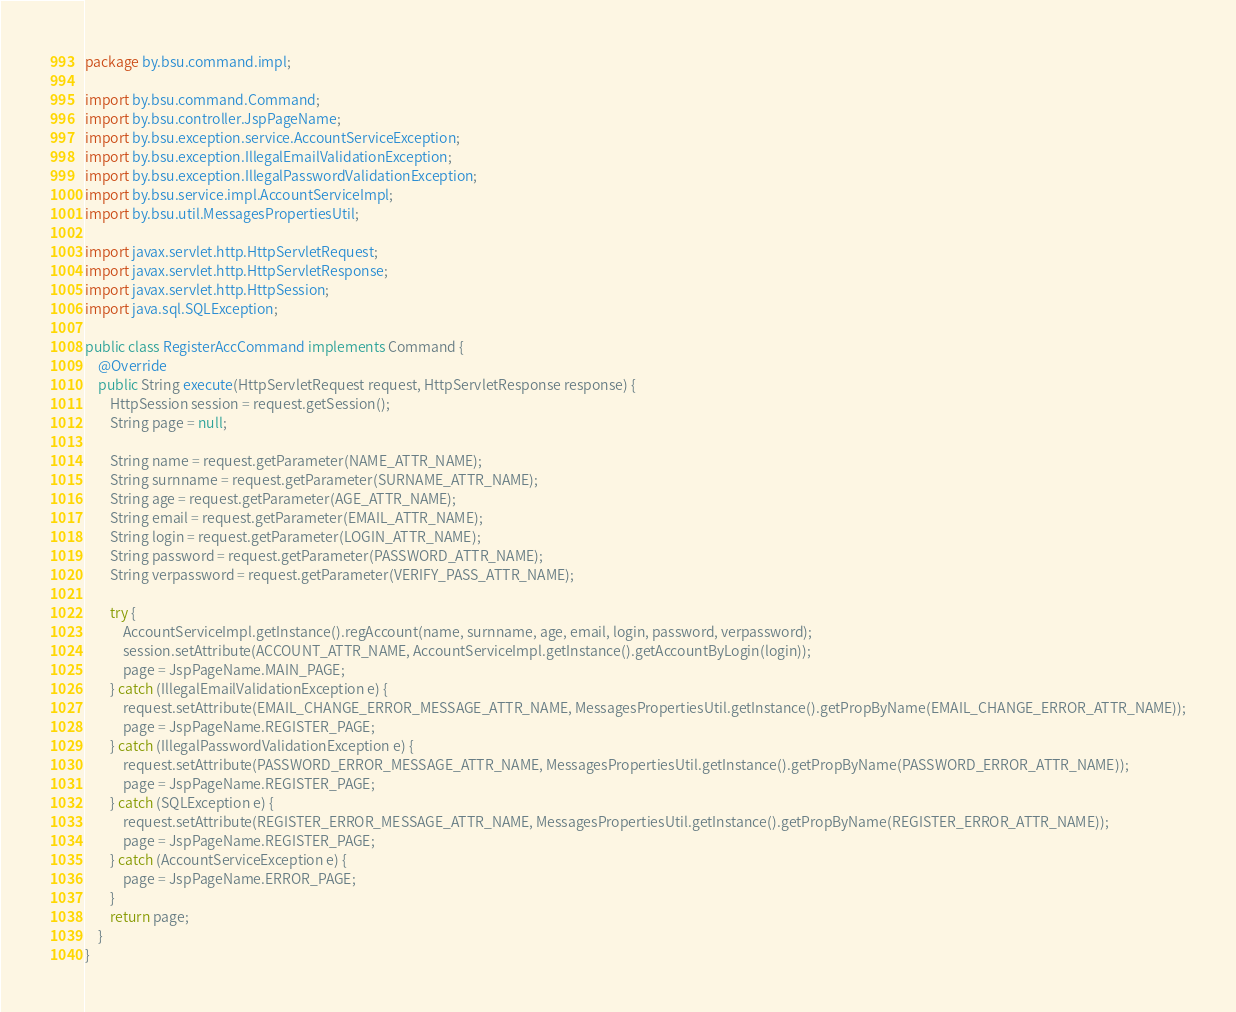Convert code to text. <code><loc_0><loc_0><loc_500><loc_500><_Java_>package by.bsu.command.impl;

import by.bsu.command.Command;
import by.bsu.controller.JspPageName;
import by.bsu.exception.service.AccountServiceException;
import by.bsu.exception.IllegalEmailValidationException;
import by.bsu.exception.IllegalPasswordValidationException;
import by.bsu.service.impl.AccountServiceImpl;
import by.bsu.util.MessagesPropertiesUtil;

import javax.servlet.http.HttpServletRequest;
import javax.servlet.http.HttpServletResponse;
import javax.servlet.http.HttpSession;
import java.sql.SQLException;

public class RegisterAccCommand implements Command {
    @Override
    public String execute(HttpServletRequest request, HttpServletResponse response) {
        HttpSession session = request.getSession();
        String page = null;

        String name = request.getParameter(NAME_ATTR_NAME);
        String surnname = request.getParameter(SURNAME_ATTR_NAME);
        String age = request.getParameter(AGE_ATTR_NAME);
        String email = request.getParameter(EMAIL_ATTR_NAME);
        String login = request.getParameter(LOGIN_ATTR_NAME);
        String password = request.getParameter(PASSWORD_ATTR_NAME);
        String verpassword = request.getParameter(VERIFY_PASS_ATTR_NAME);

        try {
            AccountServiceImpl.getInstance().regAccount(name, surnname, age, email, login, password, verpassword);
            session.setAttribute(ACCOUNT_ATTR_NAME, AccountServiceImpl.getInstance().getAccountByLogin(login));
            page = JspPageName.MAIN_PAGE;
        } catch (IllegalEmailValidationException e) {
            request.setAttribute(EMAIL_CHANGE_ERROR_MESSAGE_ATTR_NAME, MessagesPropertiesUtil.getInstance().getPropByName(EMAIL_CHANGE_ERROR_ATTR_NAME));
            page = JspPageName.REGISTER_PAGE;
        } catch (IllegalPasswordValidationException e) {
            request.setAttribute(PASSWORD_ERROR_MESSAGE_ATTR_NAME, MessagesPropertiesUtil.getInstance().getPropByName(PASSWORD_ERROR_ATTR_NAME));
            page = JspPageName.REGISTER_PAGE;
        } catch (SQLException e) {
            request.setAttribute(REGISTER_ERROR_MESSAGE_ATTR_NAME, MessagesPropertiesUtil.getInstance().getPropByName(REGISTER_ERROR_ATTR_NAME));
            page = JspPageName.REGISTER_PAGE;
        } catch (AccountServiceException e) {
            page = JspPageName.ERROR_PAGE;
        }
        return page;
    }
}
</code> 